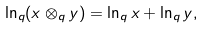Convert formula to latex. <formula><loc_0><loc_0><loc_500><loc_500>\ln _ { q } ( x \otimes _ { q } y ) = \ln _ { q } x + \ln _ { q } y ,</formula> 